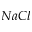Convert formula to latex. <formula><loc_0><loc_0><loc_500><loc_500>N a C l</formula> 